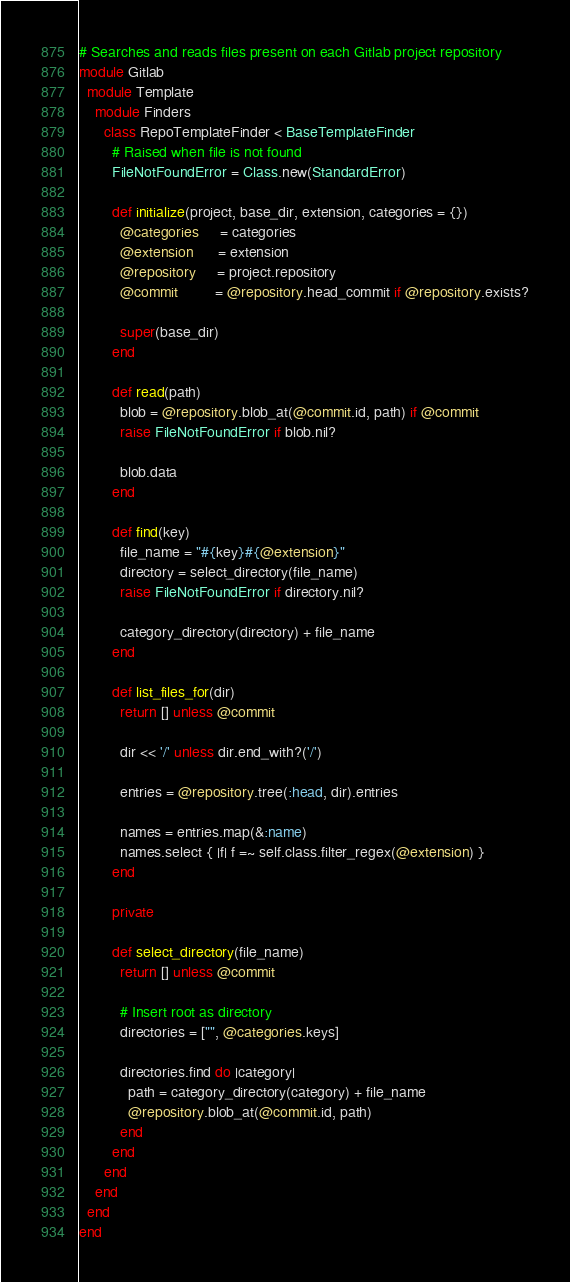<code> <loc_0><loc_0><loc_500><loc_500><_Ruby_># Searches and reads files present on each Gitlab project repository
module Gitlab
  module Template
    module Finders
      class RepoTemplateFinder < BaseTemplateFinder
        # Raised when file is not found
        FileNotFoundError = Class.new(StandardError)

        def initialize(project, base_dir, extension, categories = {})
          @categories     = categories
          @extension      = extension
          @repository     = project.repository
          @commit         = @repository.head_commit if @repository.exists?

          super(base_dir)
        end

        def read(path)
          blob = @repository.blob_at(@commit.id, path) if @commit
          raise FileNotFoundError if blob.nil?

          blob.data
        end

        def find(key)
          file_name = "#{key}#{@extension}"
          directory = select_directory(file_name)
          raise FileNotFoundError if directory.nil?

          category_directory(directory) + file_name
        end

        def list_files_for(dir)
          return [] unless @commit

          dir << '/' unless dir.end_with?('/')

          entries = @repository.tree(:head, dir).entries

          names = entries.map(&:name)
          names.select { |f| f =~ self.class.filter_regex(@extension) }
        end

        private

        def select_directory(file_name)
          return [] unless @commit

          # Insert root as directory
          directories = ["", @categories.keys]

          directories.find do |category|
            path = category_directory(category) + file_name
            @repository.blob_at(@commit.id, path)
          end
        end
      end
    end
  end
end
</code> 